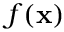<formula> <loc_0><loc_0><loc_500><loc_500>f ( x )</formula> 